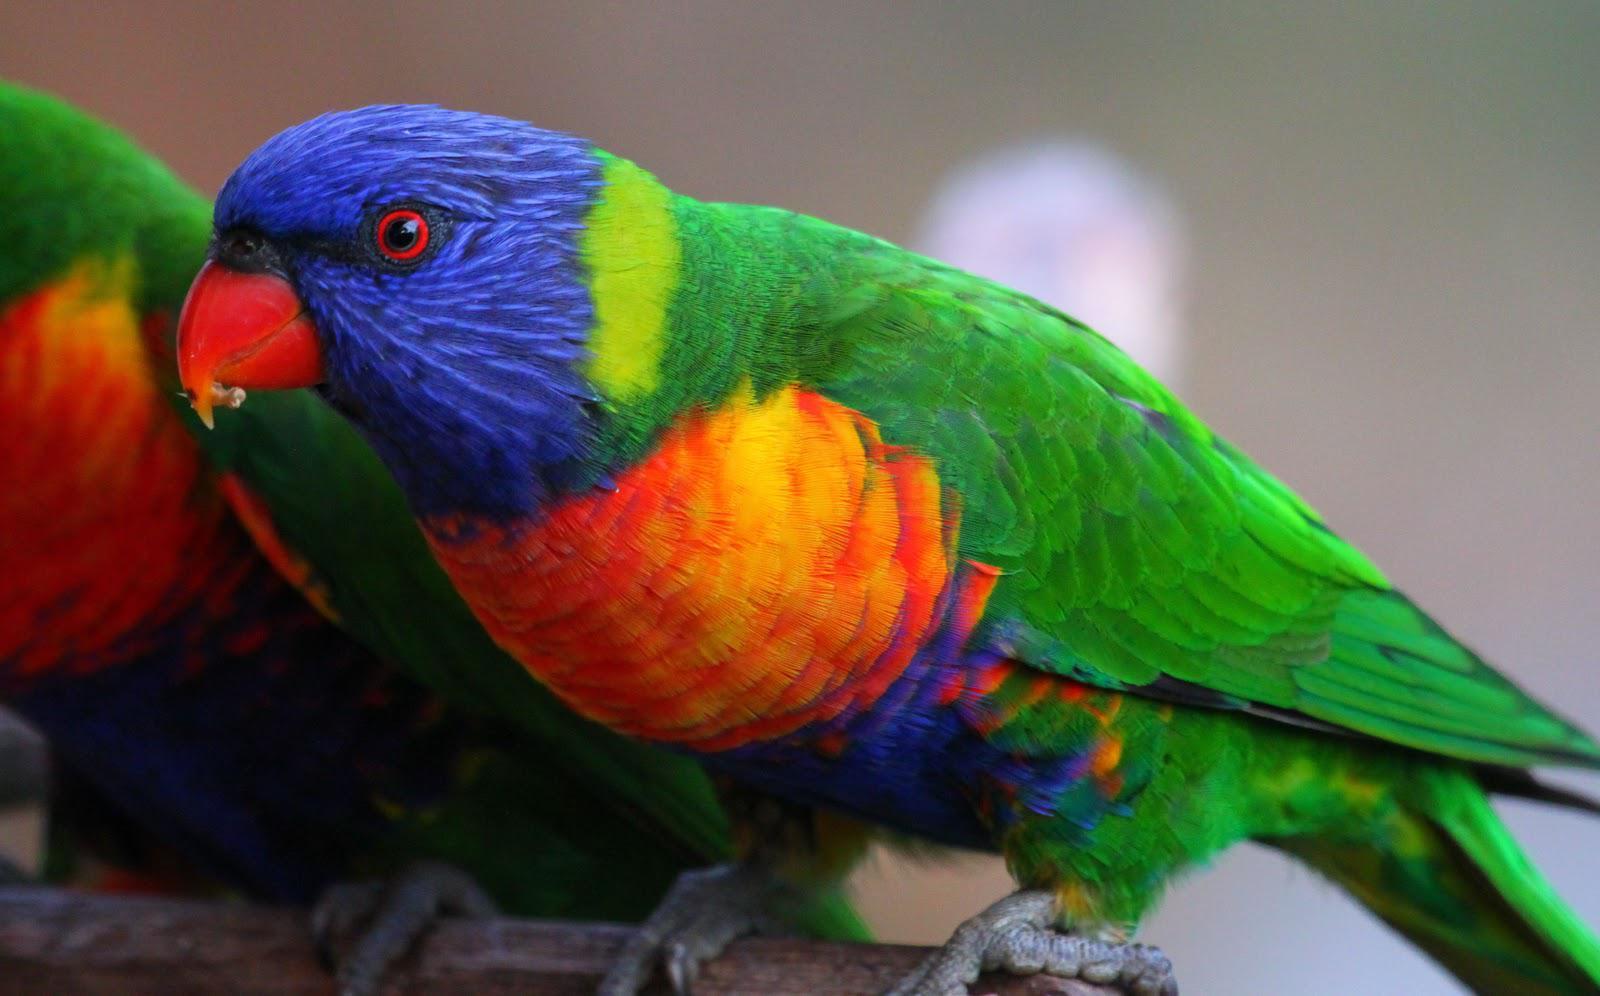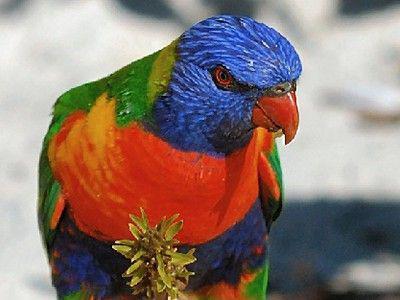The first image is the image on the left, the second image is the image on the right. For the images shown, is this caption "There are exactly two birds in the image on the left." true? Answer yes or no. Yes. The first image is the image on the left, the second image is the image on the right. Analyze the images presented: Is the assertion "More than one bird is visible, even if only partially." valid? Answer yes or no. Yes. 